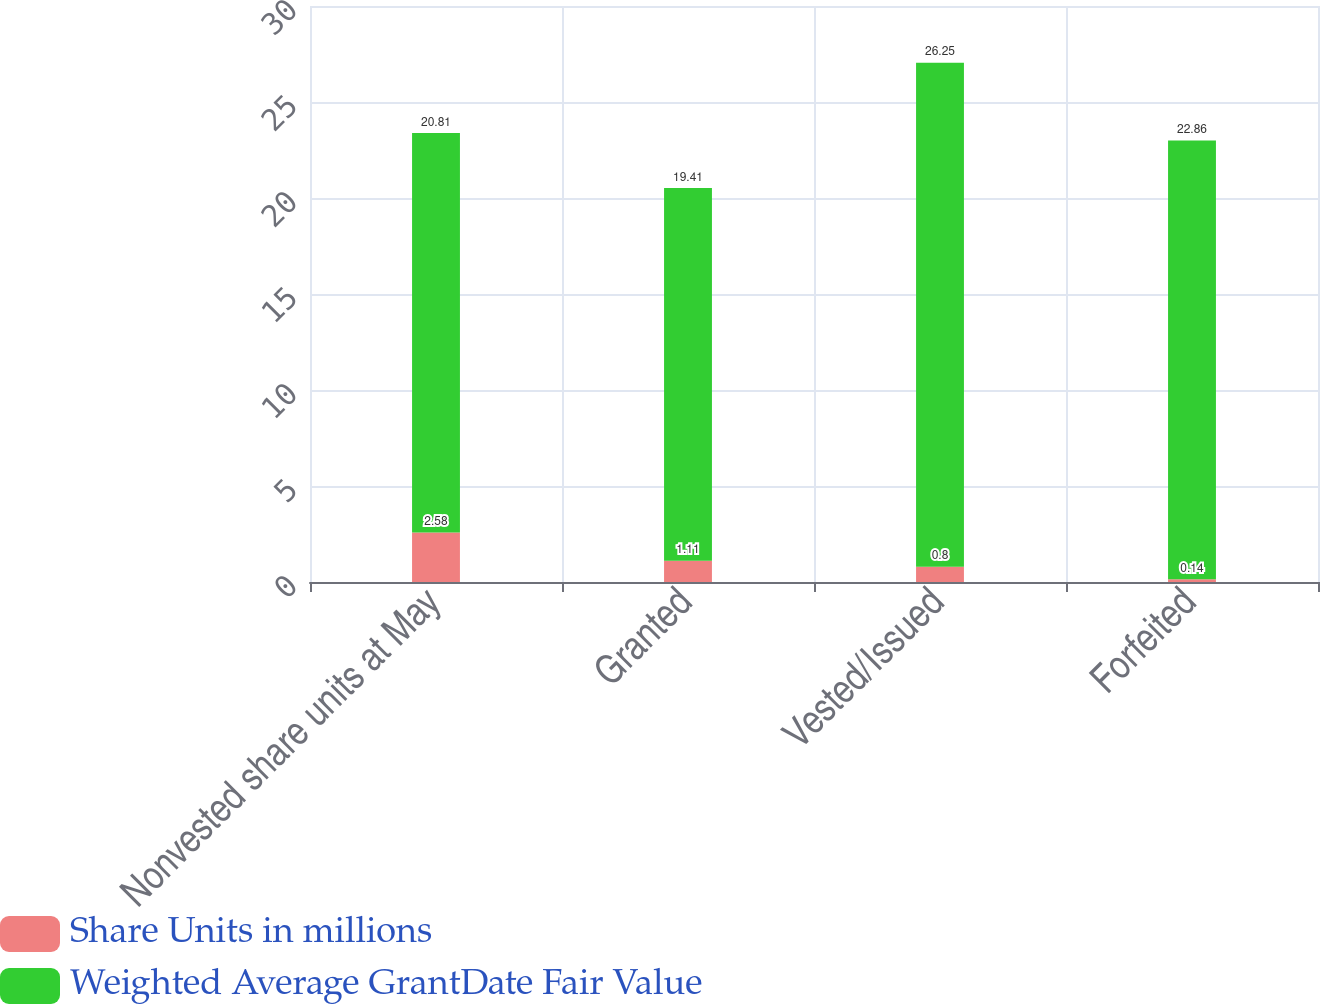Convert chart to OTSL. <chart><loc_0><loc_0><loc_500><loc_500><stacked_bar_chart><ecel><fcel>Nonvested share units at May<fcel>Granted<fcel>Vested/Issued<fcel>Forfeited<nl><fcel>Share Units in millions<fcel>2.58<fcel>1.11<fcel>0.8<fcel>0.14<nl><fcel>Weighted Average GrantDate Fair Value<fcel>20.81<fcel>19.41<fcel>26.25<fcel>22.86<nl></chart> 